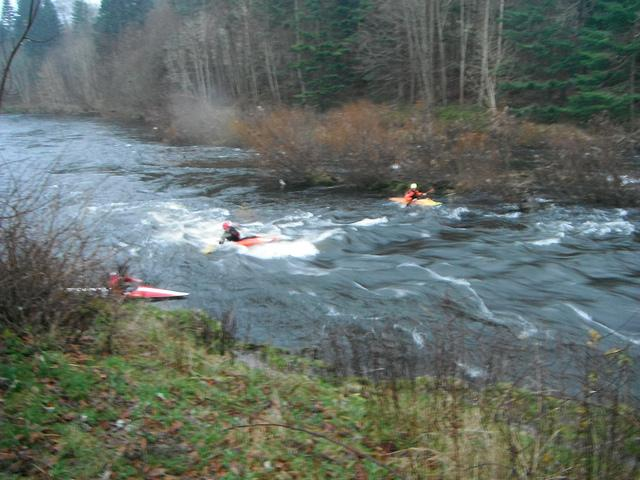Which direction are kayakers facing? Please explain your reasoning. up river. They are going against the current. 